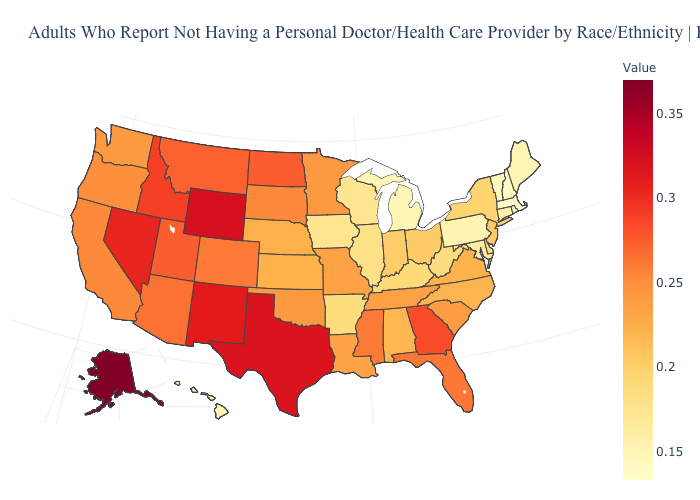Which states have the lowest value in the MidWest?
Concise answer only. Michigan. Which states have the lowest value in the South?
Write a very short answer. Maryland. Which states have the lowest value in the USA?
Keep it brief. Massachusetts. Is the legend a continuous bar?
Give a very brief answer. Yes. Does Massachusetts have the lowest value in the USA?
Give a very brief answer. Yes. Which states have the highest value in the USA?
Keep it brief. Alaska. Among the states that border Nebraska , which have the lowest value?
Write a very short answer. Iowa. 